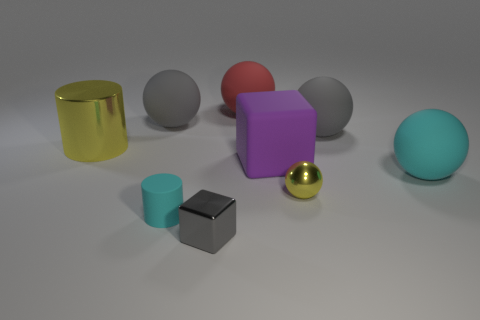Is the size of the yellow cylinder the same as the gray thing that is in front of the cyan matte sphere?
Make the answer very short. No. How many other objects are the same material as the yellow cylinder?
Make the answer very short. 2. Is there any other thing that has the same shape as the small yellow shiny thing?
Provide a succinct answer. Yes. There is a matte sphere to the left of the cyan matte object to the left of the small object in front of the tiny cyan matte cylinder; what is its color?
Your response must be concise. Gray. What shape is the rubber thing that is both behind the purple object and to the left of the big red matte sphere?
Provide a short and direct response. Sphere. Is there anything else that has the same size as the gray shiny thing?
Provide a short and direct response. Yes. The small metal thing that is to the left of the large purple object that is behind the small gray object is what color?
Your answer should be compact. Gray. What shape is the big object that is to the right of the large gray rubber thing that is on the right side of the yellow object that is on the right side of the small cyan cylinder?
Keep it short and to the point. Sphere. How big is the thing that is both in front of the big purple object and behind the small yellow metallic sphere?
Your answer should be compact. Large. How many big shiny things have the same color as the shiny sphere?
Offer a very short reply. 1. 